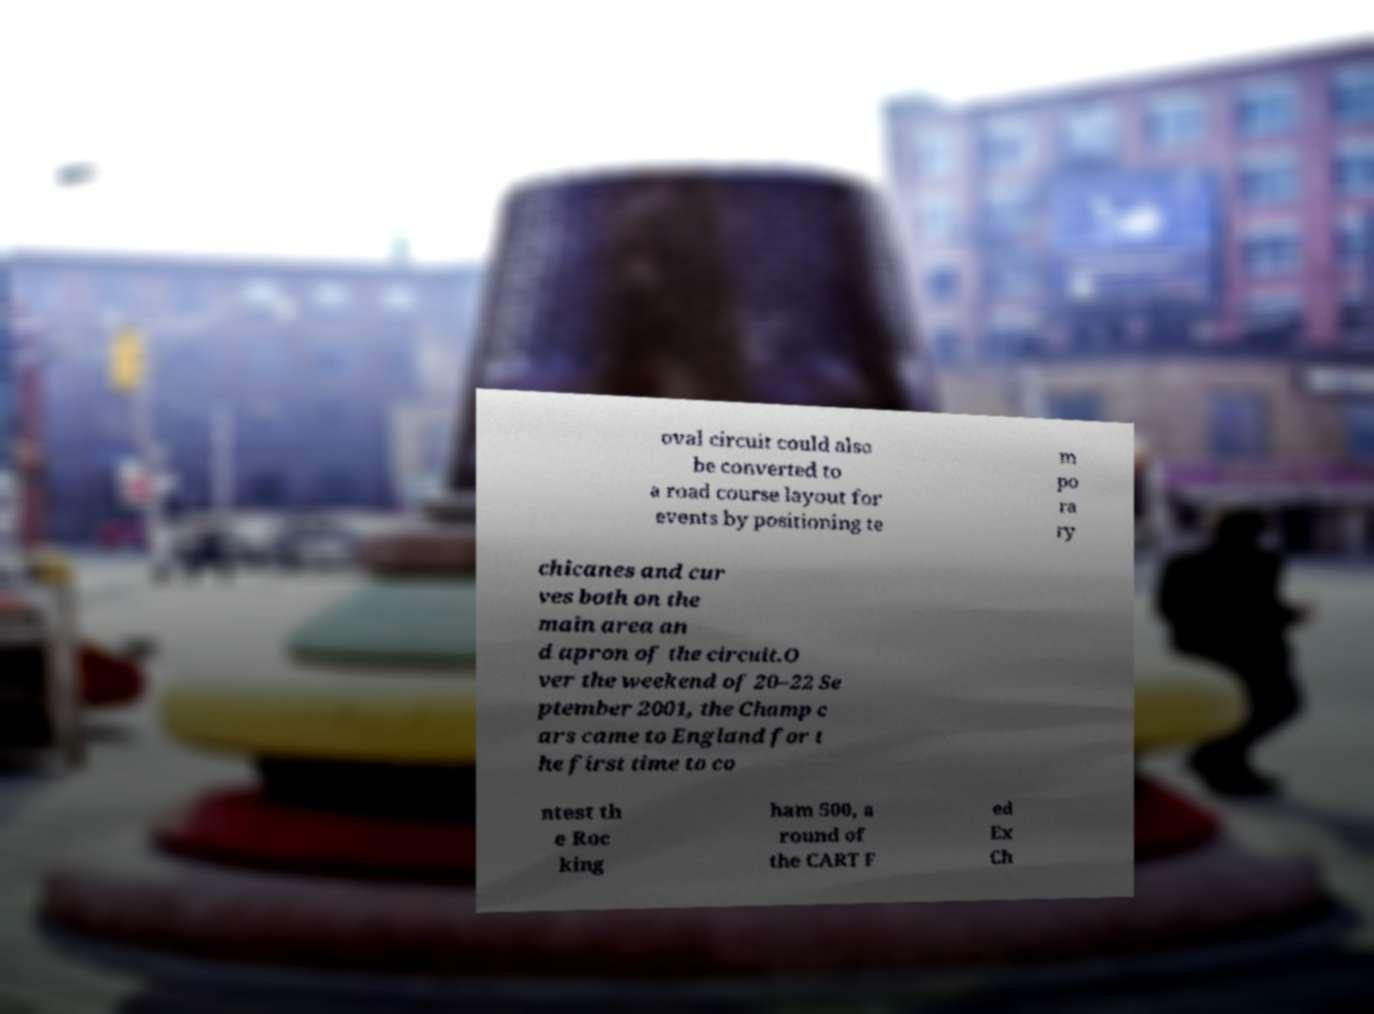What messages or text are displayed in this image? I need them in a readable, typed format. oval circuit could also be converted to a road course layout for events by positioning te m po ra ry chicanes and cur ves both on the main area an d apron of the circuit.O ver the weekend of 20–22 Se ptember 2001, the Champ c ars came to England for t he first time to co ntest th e Roc king ham 500, a round of the CART F ed Ex Ch 